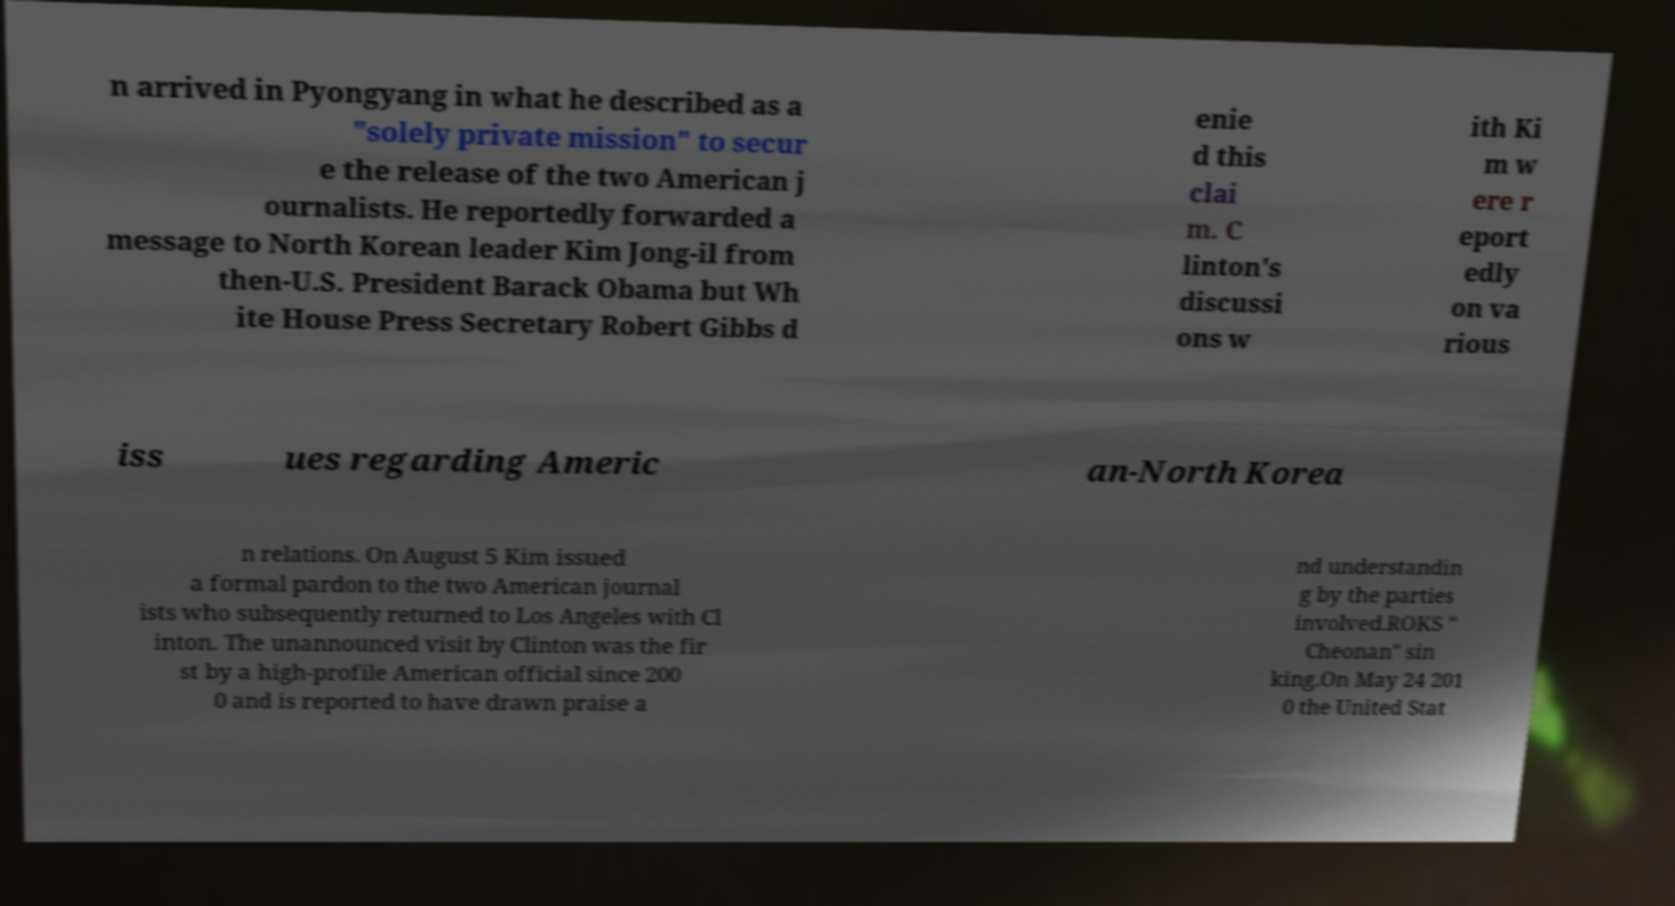For documentation purposes, I need the text within this image transcribed. Could you provide that? n arrived in Pyongyang in what he described as a "solely private mission" to secur e the release of the two American j ournalists. He reportedly forwarded a message to North Korean leader Kim Jong-il from then-U.S. President Barack Obama but Wh ite House Press Secretary Robert Gibbs d enie d this clai m. C linton's discussi ons w ith Ki m w ere r eport edly on va rious iss ues regarding Americ an-North Korea n relations. On August 5 Kim issued a formal pardon to the two American journal ists who subsequently returned to Los Angeles with Cl inton. The unannounced visit by Clinton was the fir st by a high-profile American official since 200 0 and is reported to have drawn praise a nd understandin g by the parties involved.ROKS " Cheonan" sin king.On May 24 201 0 the United Stat 